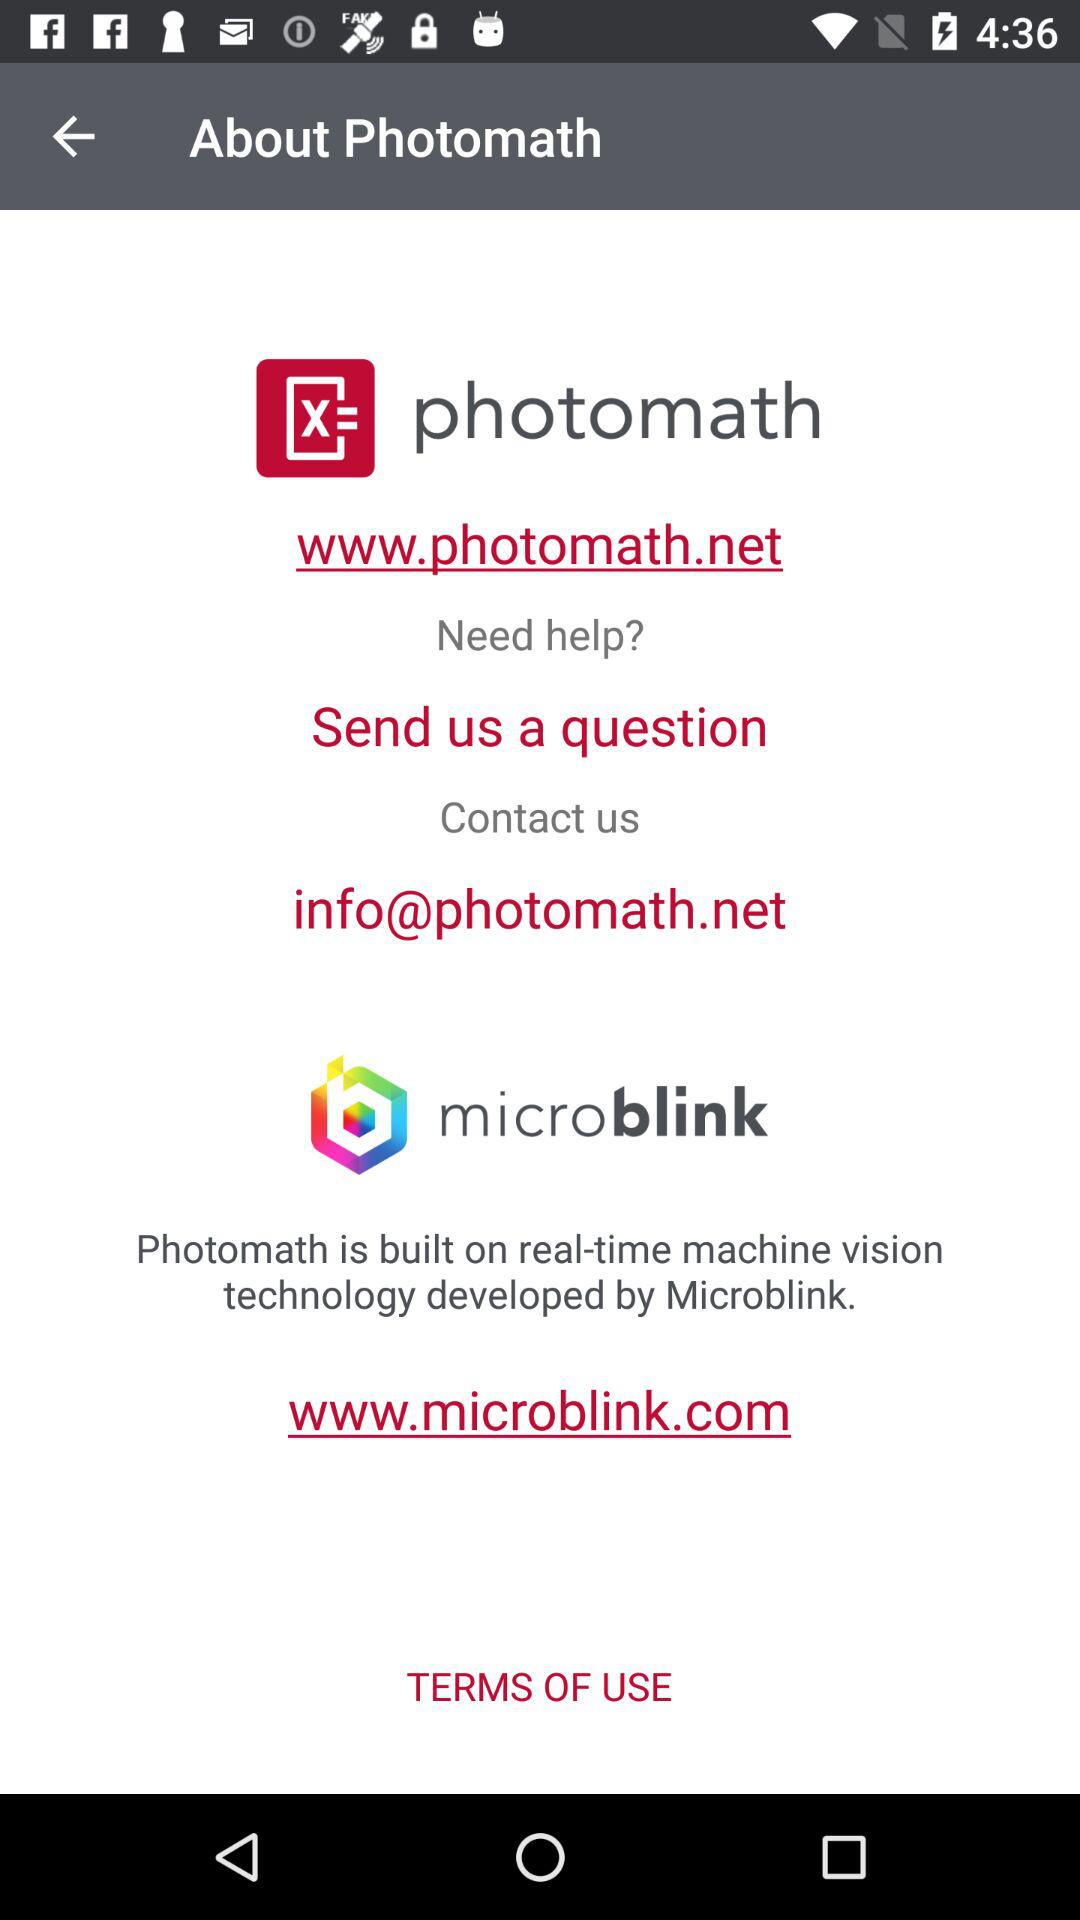What is the email address to contact? The email address to contact is info@photomath.net. 